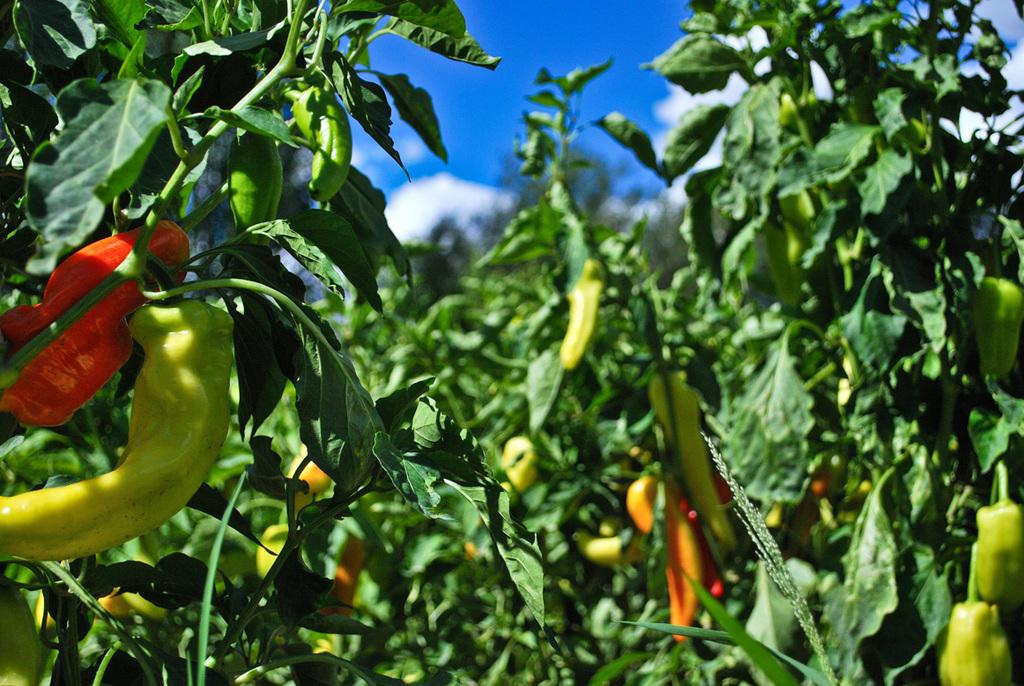What type of plants are in the image? There are chilli plants in the image. What can be seen in the background of the image? The sky is visible in the background of the image. What is the condition of the sky in the image? Clouds are present in the sky. What type of popcorn is being used to fold the key in the image? There is no popcorn or key present in the image; it features chilli plants and a sky with clouds. 